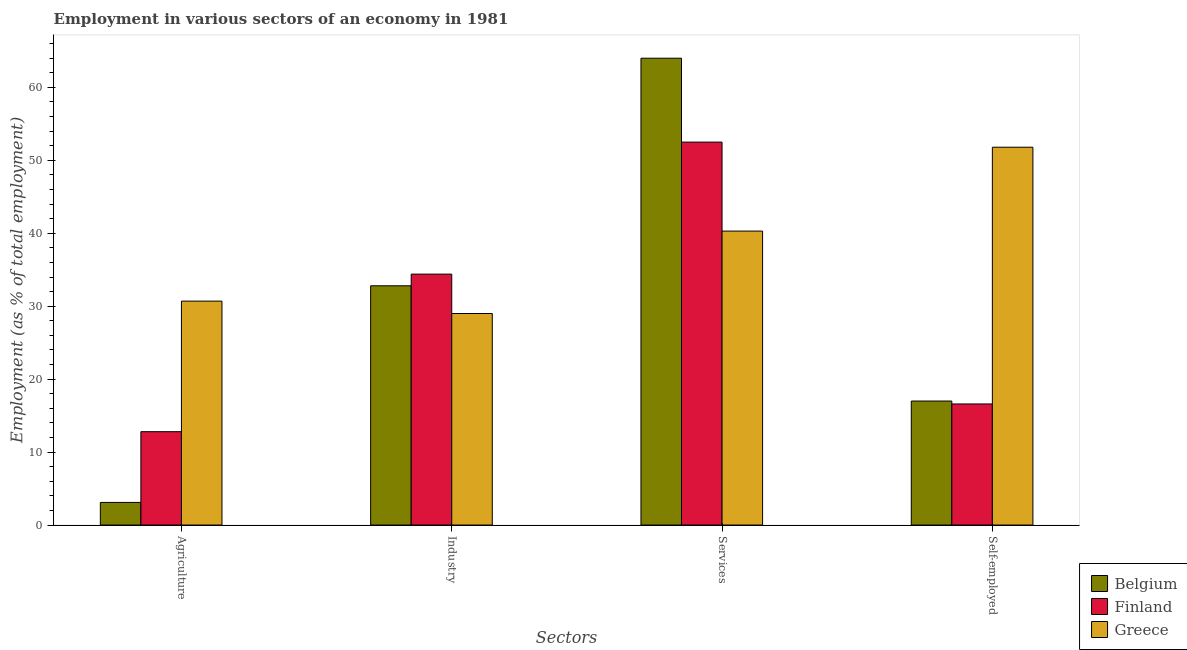How many different coloured bars are there?
Offer a terse response. 3. Are the number of bars per tick equal to the number of legend labels?
Your response must be concise. Yes. Are the number of bars on each tick of the X-axis equal?
Provide a short and direct response. Yes. How many bars are there on the 2nd tick from the right?
Your response must be concise. 3. What is the label of the 1st group of bars from the left?
Keep it short and to the point. Agriculture. What is the percentage of workers in services in Finland?
Offer a terse response. 52.5. Across all countries, what is the minimum percentage of self employed workers?
Your answer should be very brief. 16.6. In which country was the percentage of self employed workers minimum?
Your answer should be very brief. Finland. What is the total percentage of self employed workers in the graph?
Keep it short and to the point. 85.4. What is the difference between the percentage of workers in services in Greece and that in Belgium?
Give a very brief answer. -23.7. What is the difference between the percentage of workers in industry in Finland and the percentage of workers in services in Greece?
Keep it short and to the point. -5.9. What is the average percentage of workers in services per country?
Ensure brevity in your answer.  52.27. In how many countries, is the percentage of self employed workers greater than 40 %?
Provide a short and direct response. 1. What is the ratio of the percentage of workers in services in Belgium to that in Finland?
Your response must be concise. 1.22. Is the difference between the percentage of workers in agriculture in Greece and Belgium greater than the difference between the percentage of workers in industry in Greece and Belgium?
Provide a succinct answer. Yes. What is the difference between the highest and the second highest percentage of self employed workers?
Offer a terse response. 34.8. What is the difference between the highest and the lowest percentage of self employed workers?
Your response must be concise. 35.2. Is the sum of the percentage of workers in agriculture in Greece and Finland greater than the maximum percentage of workers in industry across all countries?
Make the answer very short. Yes. Is it the case that in every country, the sum of the percentage of workers in industry and percentage of workers in agriculture is greater than the sum of percentage of self employed workers and percentage of workers in services?
Ensure brevity in your answer.  No. What does the 3rd bar from the right in Self-employed represents?
Your answer should be compact. Belgium. How many countries are there in the graph?
Your response must be concise. 3. Where does the legend appear in the graph?
Provide a succinct answer. Bottom right. How are the legend labels stacked?
Your response must be concise. Vertical. What is the title of the graph?
Offer a very short reply. Employment in various sectors of an economy in 1981. What is the label or title of the X-axis?
Make the answer very short. Sectors. What is the label or title of the Y-axis?
Give a very brief answer. Employment (as % of total employment). What is the Employment (as % of total employment) of Belgium in Agriculture?
Your response must be concise. 3.1. What is the Employment (as % of total employment) in Finland in Agriculture?
Keep it short and to the point. 12.8. What is the Employment (as % of total employment) of Greece in Agriculture?
Ensure brevity in your answer.  30.7. What is the Employment (as % of total employment) in Belgium in Industry?
Your answer should be very brief. 32.8. What is the Employment (as % of total employment) in Finland in Industry?
Your response must be concise. 34.4. What is the Employment (as % of total employment) of Greece in Industry?
Provide a succinct answer. 29. What is the Employment (as % of total employment) of Finland in Services?
Offer a very short reply. 52.5. What is the Employment (as % of total employment) of Greece in Services?
Ensure brevity in your answer.  40.3. What is the Employment (as % of total employment) in Belgium in Self-employed?
Ensure brevity in your answer.  17. What is the Employment (as % of total employment) in Finland in Self-employed?
Your answer should be very brief. 16.6. What is the Employment (as % of total employment) in Greece in Self-employed?
Your answer should be very brief. 51.8. Across all Sectors, what is the maximum Employment (as % of total employment) in Finland?
Keep it short and to the point. 52.5. Across all Sectors, what is the maximum Employment (as % of total employment) in Greece?
Your response must be concise. 51.8. Across all Sectors, what is the minimum Employment (as % of total employment) of Belgium?
Keep it short and to the point. 3.1. Across all Sectors, what is the minimum Employment (as % of total employment) in Finland?
Your answer should be very brief. 12.8. What is the total Employment (as % of total employment) in Belgium in the graph?
Keep it short and to the point. 116.9. What is the total Employment (as % of total employment) in Finland in the graph?
Offer a terse response. 116.3. What is the total Employment (as % of total employment) of Greece in the graph?
Provide a short and direct response. 151.8. What is the difference between the Employment (as % of total employment) of Belgium in Agriculture and that in Industry?
Offer a terse response. -29.7. What is the difference between the Employment (as % of total employment) in Finland in Agriculture and that in Industry?
Offer a terse response. -21.6. What is the difference between the Employment (as % of total employment) in Belgium in Agriculture and that in Services?
Make the answer very short. -60.9. What is the difference between the Employment (as % of total employment) of Finland in Agriculture and that in Services?
Offer a terse response. -39.7. What is the difference between the Employment (as % of total employment) in Greece in Agriculture and that in Self-employed?
Keep it short and to the point. -21.1. What is the difference between the Employment (as % of total employment) of Belgium in Industry and that in Services?
Keep it short and to the point. -31.2. What is the difference between the Employment (as % of total employment) of Finland in Industry and that in Services?
Your answer should be compact. -18.1. What is the difference between the Employment (as % of total employment) in Greece in Industry and that in Services?
Your response must be concise. -11.3. What is the difference between the Employment (as % of total employment) of Belgium in Industry and that in Self-employed?
Give a very brief answer. 15.8. What is the difference between the Employment (as % of total employment) of Finland in Industry and that in Self-employed?
Your response must be concise. 17.8. What is the difference between the Employment (as % of total employment) of Greece in Industry and that in Self-employed?
Make the answer very short. -22.8. What is the difference between the Employment (as % of total employment) in Finland in Services and that in Self-employed?
Ensure brevity in your answer.  35.9. What is the difference between the Employment (as % of total employment) in Greece in Services and that in Self-employed?
Your answer should be compact. -11.5. What is the difference between the Employment (as % of total employment) of Belgium in Agriculture and the Employment (as % of total employment) of Finland in Industry?
Provide a succinct answer. -31.3. What is the difference between the Employment (as % of total employment) of Belgium in Agriculture and the Employment (as % of total employment) of Greece in Industry?
Make the answer very short. -25.9. What is the difference between the Employment (as % of total employment) in Finland in Agriculture and the Employment (as % of total employment) in Greece in Industry?
Your answer should be compact. -16.2. What is the difference between the Employment (as % of total employment) in Belgium in Agriculture and the Employment (as % of total employment) in Finland in Services?
Your answer should be compact. -49.4. What is the difference between the Employment (as % of total employment) in Belgium in Agriculture and the Employment (as % of total employment) in Greece in Services?
Keep it short and to the point. -37.2. What is the difference between the Employment (as % of total employment) of Finland in Agriculture and the Employment (as % of total employment) of Greece in Services?
Make the answer very short. -27.5. What is the difference between the Employment (as % of total employment) in Belgium in Agriculture and the Employment (as % of total employment) in Greece in Self-employed?
Ensure brevity in your answer.  -48.7. What is the difference between the Employment (as % of total employment) of Finland in Agriculture and the Employment (as % of total employment) of Greece in Self-employed?
Your answer should be compact. -39. What is the difference between the Employment (as % of total employment) of Belgium in Industry and the Employment (as % of total employment) of Finland in Services?
Offer a very short reply. -19.7. What is the difference between the Employment (as % of total employment) in Belgium in Industry and the Employment (as % of total employment) in Greece in Services?
Your answer should be compact. -7.5. What is the difference between the Employment (as % of total employment) in Finland in Industry and the Employment (as % of total employment) in Greece in Services?
Provide a succinct answer. -5.9. What is the difference between the Employment (as % of total employment) of Belgium in Industry and the Employment (as % of total employment) of Finland in Self-employed?
Provide a succinct answer. 16.2. What is the difference between the Employment (as % of total employment) in Finland in Industry and the Employment (as % of total employment) in Greece in Self-employed?
Give a very brief answer. -17.4. What is the difference between the Employment (as % of total employment) in Belgium in Services and the Employment (as % of total employment) in Finland in Self-employed?
Provide a succinct answer. 47.4. What is the difference between the Employment (as % of total employment) of Belgium in Services and the Employment (as % of total employment) of Greece in Self-employed?
Provide a short and direct response. 12.2. What is the average Employment (as % of total employment) of Belgium per Sectors?
Make the answer very short. 29.23. What is the average Employment (as % of total employment) of Finland per Sectors?
Make the answer very short. 29.07. What is the average Employment (as % of total employment) of Greece per Sectors?
Keep it short and to the point. 37.95. What is the difference between the Employment (as % of total employment) of Belgium and Employment (as % of total employment) of Greece in Agriculture?
Your answer should be very brief. -27.6. What is the difference between the Employment (as % of total employment) in Finland and Employment (as % of total employment) in Greece in Agriculture?
Your response must be concise. -17.9. What is the difference between the Employment (as % of total employment) in Belgium and Employment (as % of total employment) in Finland in Industry?
Offer a very short reply. -1.6. What is the difference between the Employment (as % of total employment) of Belgium and Employment (as % of total employment) of Greece in Industry?
Provide a short and direct response. 3.8. What is the difference between the Employment (as % of total employment) in Belgium and Employment (as % of total employment) in Greece in Services?
Offer a very short reply. 23.7. What is the difference between the Employment (as % of total employment) in Belgium and Employment (as % of total employment) in Finland in Self-employed?
Your answer should be very brief. 0.4. What is the difference between the Employment (as % of total employment) in Belgium and Employment (as % of total employment) in Greece in Self-employed?
Make the answer very short. -34.8. What is the difference between the Employment (as % of total employment) of Finland and Employment (as % of total employment) of Greece in Self-employed?
Your answer should be compact. -35.2. What is the ratio of the Employment (as % of total employment) in Belgium in Agriculture to that in Industry?
Ensure brevity in your answer.  0.09. What is the ratio of the Employment (as % of total employment) of Finland in Agriculture to that in Industry?
Ensure brevity in your answer.  0.37. What is the ratio of the Employment (as % of total employment) in Greece in Agriculture to that in Industry?
Your answer should be very brief. 1.06. What is the ratio of the Employment (as % of total employment) of Belgium in Agriculture to that in Services?
Keep it short and to the point. 0.05. What is the ratio of the Employment (as % of total employment) of Finland in Agriculture to that in Services?
Ensure brevity in your answer.  0.24. What is the ratio of the Employment (as % of total employment) of Greece in Agriculture to that in Services?
Your answer should be compact. 0.76. What is the ratio of the Employment (as % of total employment) in Belgium in Agriculture to that in Self-employed?
Your response must be concise. 0.18. What is the ratio of the Employment (as % of total employment) in Finland in Agriculture to that in Self-employed?
Your answer should be compact. 0.77. What is the ratio of the Employment (as % of total employment) in Greece in Agriculture to that in Self-employed?
Offer a very short reply. 0.59. What is the ratio of the Employment (as % of total employment) of Belgium in Industry to that in Services?
Make the answer very short. 0.51. What is the ratio of the Employment (as % of total employment) of Finland in Industry to that in Services?
Keep it short and to the point. 0.66. What is the ratio of the Employment (as % of total employment) in Greece in Industry to that in Services?
Your response must be concise. 0.72. What is the ratio of the Employment (as % of total employment) in Belgium in Industry to that in Self-employed?
Provide a short and direct response. 1.93. What is the ratio of the Employment (as % of total employment) in Finland in Industry to that in Self-employed?
Your response must be concise. 2.07. What is the ratio of the Employment (as % of total employment) in Greece in Industry to that in Self-employed?
Offer a very short reply. 0.56. What is the ratio of the Employment (as % of total employment) of Belgium in Services to that in Self-employed?
Offer a terse response. 3.76. What is the ratio of the Employment (as % of total employment) of Finland in Services to that in Self-employed?
Your answer should be very brief. 3.16. What is the ratio of the Employment (as % of total employment) of Greece in Services to that in Self-employed?
Provide a short and direct response. 0.78. What is the difference between the highest and the second highest Employment (as % of total employment) of Belgium?
Make the answer very short. 31.2. What is the difference between the highest and the second highest Employment (as % of total employment) of Finland?
Provide a succinct answer. 18.1. What is the difference between the highest and the second highest Employment (as % of total employment) in Greece?
Ensure brevity in your answer.  11.5. What is the difference between the highest and the lowest Employment (as % of total employment) in Belgium?
Provide a succinct answer. 60.9. What is the difference between the highest and the lowest Employment (as % of total employment) in Finland?
Give a very brief answer. 39.7. What is the difference between the highest and the lowest Employment (as % of total employment) in Greece?
Offer a very short reply. 22.8. 